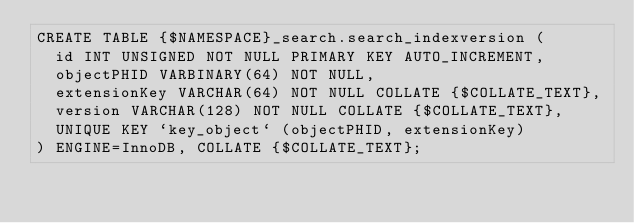Convert code to text. <code><loc_0><loc_0><loc_500><loc_500><_SQL_>CREATE TABLE {$NAMESPACE}_search.search_indexversion (
  id INT UNSIGNED NOT NULL PRIMARY KEY AUTO_INCREMENT,
  objectPHID VARBINARY(64) NOT NULL,
  extensionKey VARCHAR(64) NOT NULL COLLATE {$COLLATE_TEXT},
  version VARCHAR(128) NOT NULL COLLATE {$COLLATE_TEXT},
  UNIQUE KEY `key_object` (objectPHID, extensionKey)
) ENGINE=InnoDB, COLLATE {$COLLATE_TEXT};
</code> 